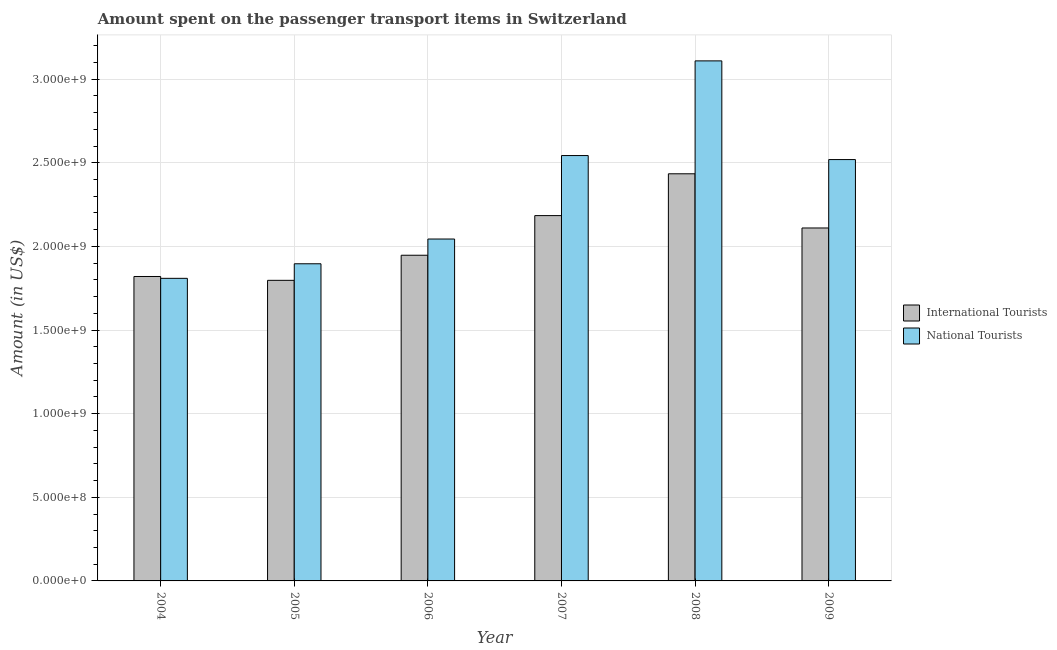How many groups of bars are there?
Your answer should be compact. 6. Are the number of bars per tick equal to the number of legend labels?
Provide a short and direct response. Yes. How many bars are there on the 4th tick from the left?
Make the answer very short. 2. How many bars are there on the 2nd tick from the right?
Offer a terse response. 2. What is the label of the 5th group of bars from the left?
Offer a terse response. 2008. In how many cases, is the number of bars for a given year not equal to the number of legend labels?
Provide a short and direct response. 0. What is the amount spent on transport items of international tourists in 2005?
Your answer should be compact. 1.80e+09. Across all years, what is the maximum amount spent on transport items of international tourists?
Ensure brevity in your answer.  2.43e+09. Across all years, what is the minimum amount spent on transport items of international tourists?
Provide a succinct answer. 1.80e+09. In which year was the amount spent on transport items of national tourists minimum?
Provide a short and direct response. 2004. What is the total amount spent on transport items of national tourists in the graph?
Provide a short and direct response. 1.39e+1. What is the difference between the amount spent on transport items of international tourists in 2008 and that in 2009?
Make the answer very short. 3.24e+08. What is the difference between the amount spent on transport items of national tourists in 2006 and the amount spent on transport items of international tourists in 2007?
Ensure brevity in your answer.  -4.99e+08. What is the average amount spent on transport items of international tourists per year?
Your answer should be compact. 2.05e+09. What is the ratio of the amount spent on transport items of international tourists in 2005 to that in 2009?
Give a very brief answer. 0.85. Is the amount spent on transport items of international tourists in 2007 less than that in 2008?
Ensure brevity in your answer.  Yes. Is the difference between the amount spent on transport items of international tourists in 2008 and 2009 greater than the difference between the amount spent on transport items of national tourists in 2008 and 2009?
Ensure brevity in your answer.  No. What is the difference between the highest and the second highest amount spent on transport items of national tourists?
Your response must be concise. 5.66e+08. What is the difference between the highest and the lowest amount spent on transport items of international tourists?
Ensure brevity in your answer.  6.37e+08. In how many years, is the amount spent on transport items of national tourists greater than the average amount spent on transport items of national tourists taken over all years?
Provide a short and direct response. 3. Is the sum of the amount spent on transport items of national tourists in 2007 and 2009 greater than the maximum amount spent on transport items of international tourists across all years?
Your response must be concise. Yes. What does the 2nd bar from the left in 2005 represents?
Offer a terse response. National Tourists. What does the 1st bar from the right in 2007 represents?
Offer a very short reply. National Tourists. Are the values on the major ticks of Y-axis written in scientific E-notation?
Provide a succinct answer. Yes. Where does the legend appear in the graph?
Your answer should be compact. Center right. What is the title of the graph?
Provide a short and direct response. Amount spent on the passenger transport items in Switzerland. Does "constant 2005 US$" appear as one of the legend labels in the graph?
Offer a very short reply. No. What is the label or title of the X-axis?
Your response must be concise. Year. What is the label or title of the Y-axis?
Provide a succinct answer. Amount (in US$). What is the Amount (in US$) of International Tourists in 2004?
Make the answer very short. 1.82e+09. What is the Amount (in US$) in National Tourists in 2004?
Your answer should be very brief. 1.81e+09. What is the Amount (in US$) of International Tourists in 2005?
Keep it short and to the point. 1.80e+09. What is the Amount (in US$) in National Tourists in 2005?
Offer a terse response. 1.90e+09. What is the Amount (in US$) in International Tourists in 2006?
Your answer should be very brief. 1.95e+09. What is the Amount (in US$) in National Tourists in 2006?
Keep it short and to the point. 2.04e+09. What is the Amount (in US$) in International Tourists in 2007?
Offer a terse response. 2.18e+09. What is the Amount (in US$) in National Tourists in 2007?
Make the answer very short. 2.54e+09. What is the Amount (in US$) in International Tourists in 2008?
Your response must be concise. 2.43e+09. What is the Amount (in US$) of National Tourists in 2008?
Keep it short and to the point. 3.11e+09. What is the Amount (in US$) of International Tourists in 2009?
Your response must be concise. 2.11e+09. What is the Amount (in US$) in National Tourists in 2009?
Provide a short and direct response. 2.52e+09. Across all years, what is the maximum Amount (in US$) in International Tourists?
Your response must be concise. 2.43e+09. Across all years, what is the maximum Amount (in US$) of National Tourists?
Provide a short and direct response. 3.11e+09. Across all years, what is the minimum Amount (in US$) in International Tourists?
Keep it short and to the point. 1.80e+09. Across all years, what is the minimum Amount (in US$) in National Tourists?
Provide a succinct answer. 1.81e+09. What is the total Amount (in US$) in International Tourists in the graph?
Make the answer very short. 1.23e+1. What is the total Amount (in US$) of National Tourists in the graph?
Provide a succinct answer. 1.39e+1. What is the difference between the Amount (in US$) in International Tourists in 2004 and that in 2005?
Keep it short and to the point. 2.30e+07. What is the difference between the Amount (in US$) of National Tourists in 2004 and that in 2005?
Give a very brief answer. -8.70e+07. What is the difference between the Amount (in US$) of International Tourists in 2004 and that in 2006?
Offer a very short reply. -1.27e+08. What is the difference between the Amount (in US$) in National Tourists in 2004 and that in 2006?
Your response must be concise. -2.35e+08. What is the difference between the Amount (in US$) in International Tourists in 2004 and that in 2007?
Offer a terse response. -3.64e+08. What is the difference between the Amount (in US$) of National Tourists in 2004 and that in 2007?
Offer a very short reply. -7.34e+08. What is the difference between the Amount (in US$) of International Tourists in 2004 and that in 2008?
Give a very brief answer. -6.14e+08. What is the difference between the Amount (in US$) in National Tourists in 2004 and that in 2008?
Keep it short and to the point. -1.30e+09. What is the difference between the Amount (in US$) of International Tourists in 2004 and that in 2009?
Offer a very short reply. -2.90e+08. What is the difference between the Amount (in US$) of National Tourists in 2004 and that in 2009?
Your answer should be very brief. -7.10e+08. What is the difference between the Amount (in US$) in International Tourists in 2005 and that in 2006?
Ensure brevity in your answer.  -1.50e+08. What is the difference between the Amount (in US$) of National Tourists in 2005 and that in 2006?
Keep it short and to the point. -1.48e+08. What is the difference between the Amount (in US$) in International Tourists in 2005 and that in 2007?
Your answer should be very brief. -3.87e+08. What is the difference between the Amount (in US$) of National Tourists in 2005 and that in 2007?
Your answer should be compact. -6.47e+08. What is the difference between the Amount (in US$) in International Tourists in 2005 and that in 2008?
Offer a very short reply. -6.37e+08. What is the difference between the Amount (in US$) in National Tourists in 2005 and that in 2008?
Keep it short and to the point. -1.21e+09. What is the difference between the Amount (in US$) of International Tourists in 2005 and that in 2009?
Give a very brief answer. -3.13e+08. What is the difference between the Amount (in US$) of National Tourists in 2005 and that in 2009?
Your answer should be compact. -6.23e+08. What is the difference between the Amount (in US$) of International Tourists in 2006 and that in 2007?
Your answer should be very brief. -2.37e+08. What is the difference between the Amount (in US$) in National Tourists in 2006 and that in 2007?
Offer a terse response. -4.99e+08. What is the difference between the Amount (in US$) of International Tourists in 2006 and that in 2008?
Make the answer very short. -4.87e+08. What is the difference between the Amount (in US$) in National Tourists in 2006 and that in 2008?
Your answer should be compact. -1.06e+09. What is the difference between the Amount (in US$) in International Tourists in 2006 and that in 2009?
Your answer should be compact. -1.63e+08. What is the difference between the Amount (in US$) in National Tourists in 2006 and that in 2009?
Provide a succinct answer. -4.75e+08. What is the difference between the Amount (in US$) in International Tourists in 2007 and that in 2008?
Provide a succinct answer. -2.50e+08. What is the difference between the Amount (in US$) in National Tourists in 2007 and that in 2008?
Give a very brief answer. -5.66e+08. What is the difference between the Amount (in US$) of International Tourists in 2007 and that in 2009?
Keep it short and to the point. 7.40e+07. What is the difference between the Amount (in US$) of National Tourists in 2007 and that in 2009?
Your answer should be very brief. 2.40e+07. What is the difference between the Amount (in US$) of International Tourists in 2008 and that in 2009?
Make the answer very short. 3.24e+08. What is the difference between the Amount (in US$) of National Tourists in 2008 and that in 2009?
Your answer should be compact. 5.90e+08. What is the difference between the Amount (in US$) of International Tourists in 2004 and the Amount (in US$) of National Tourists in 2005?
Offer a terse response. -7.60e+07. What is the difference between the Amount (in US$) in International Tourists in 2004 and the Amount (in US$) in National Tourists in 2006?
Give a very brief answer. -2.24e+08. What is the difference between the Amount (in US$) of International Tourists in 2004 and the Amount (in US$) of National Tourists in 2007?
Ensure brevity in your answer.  -7.23e+08. What is the difference between the Amount (in US$) of International Tourists in 2004 and the Amount (in US$) of National Tourists in 2008?
Provide a short and direct response. -1.29e+09. What is the difference between the Amount (in US$) of International Tourists in 2004 and the Amount (in US$) of National Tourists in 2009?
Your answer should be compact. -6.99e+08. What is the difference between the Amount (in US$) in International Tourists in 2005 and the Amount (in US$) in National Tourists in 2006?
Offer a very short reply. -2.47e+08. What is the difference between the Amount (in US$) in International Tourists in 2005 and the Amount (in US$) in National Tourists in 2007?
Ensure brevity in your answer.  -7.46e+08. What is the difference between the Amount (in US$) in International Tourists in 2005 and the Amount (in US$) in National Tourists in 2008?
Provide a succinct answer. -1.31e+09. What is the difference between the Amount (in US$) of International Tourists in 2005 and the Amount (in US$) of National Tourists in 2009?
Your answer should be compact. -7.22e+08. What is the difference between the Amount (in US$) in International Tourists in 2006 and the Amount (in US$) in National Tourists in 2007?
Ensure brevity in your answer.  -5.96e+08. What is the difference between the Amount (in US$) in International Tourists in 2006 and the Amount (in US$) in National Tourists in 2008?
Offer a terse response. -1.16e+09. What is the difference between the Amount (in US$) of International Tourists in 2006 and the Amount (in US$) of National Tourists in 2009?
Give a very brief answer. -5.72e+08. What is the difference between the Amount (in US$) of International Tourists in 2007 and the Amount (in US$) of National Tourists in 2008?
Your response must be concise. -9.25e+08. What is the difference between the Amount (in US$) of International Tourists in 2007 and the Amount (in US$) of National Tourists in 2009?
Your response must be concise. -3.35e+08. What is the difference between the Amount (in US$) in International Tourists in 2008 and the Amount (in US$) in National Tourists in 2009?
Make the answer very short. -8.50e+07. What is the average Amount (in US$) of International Tourists per year?
Ensure brevity in your answer.  2.05e+09. What is the average Amount (in US$) in National Tourists per year?
Your answer should be compact. 2.32e+09. In the year 2004, what is the difference between the Amount (in US$) in International Tourists and Amount (in US$) in National Tourists?
Give a very brief answer. 1.10e+07. In the year 2005, what is the difference between the Amount (in US$) in International Tourists and Amount (in US$) in National Tourists?
Your answer should be very brief. -9.90e+07. In the year 2006, what is the difference between the Amount (in US$) in International Tourists and Amount (in US$) in National Tourists?
Ensure brevity in your answer.  -9.70e+07. In the year 2007, what is the difference between the Amount (in US$) in International Tourists and Amount (in US$) in National Tourists?
Your response must be concise. -3.59e+08. In the year 2008, what is the difference between the Amount (in US$) of International Tourists and Amount (in US$) of National Tourists?
Your response must be concise. -6.75e+08. In the year 2009, what is the difference between the Amount (in US$) in International Tourists and Amount (in US$) in National Tourists?
Make the answer very short. -4.09e+08. What is the ratio of the Amount (in US$) in International Tourists in 2004 to that in 2005?
Keep it short and to the point. 1.01. What is the ratio of the Amount (in US$) of National Tourists in 2004 to that in 2005?
Give a very brief answer. 0.95. What is the ratio of the Amount (in US$) in International Tourists in 2004 to that in 2006?
Offer a very short reply. 0.93. What is the ratio of the Amount (in US$) of National Tourists in 2004 to that in 2006?
Ensure brevity in your answer.  0.89. What is the ratio of the Amount (in US$) of National Tourists in 2004 to that in 2007?
Your response must be concise. 0.71. What is the ratio of the Amount (in US$) of International Tourists in 2004 to that in 2008?
Make the answer very short. 0.75. What is the ratio of the Amount (in US$) in National Tourists in 2004 to that in 2008?
Give a very brief answer. 0.58. What is the ratio of the Amount (in US$) in International Tourists in 2004 to that in 2009?
Give a very brief answer. 0.86. What is the ratio of the Amount (in US$) in National Tourists in 2004 to that in 2009?
Provide a short and direct response. 0.72. What is the ratio of the Amount (in US$) in International Tourists in 2005 to that in 2006?
Make the answer very short. 0.92. What is the ratio of the Amount (in US$) in National Tourists in 2005 to that in 2006?
Your answer should be compact. 0.93. What is the ratio of the Amount (in US$) of International Tourists in 2005 to that in 2007?
Give a very brief answer. 0.82. What is the ratio of the Amount (in US$) in National Tourists in 2005 to that in 2007?
Provide a succinct answer. 0.75. What is the ratio of the Amount (in US$) of International Tourists in 2005 to that in 2008?
Offer a terse response. 0.74. What is the ratio of the Amount (in US$) in National Tourists in 2005 to that in 2008?
Provide a succinct answer. 0.61. What is the ratio of the Amount (in US$) of International Tourists in 2005 to that in 2009?
Make the answer very short. 0.85. What is the ratio of the Amount (in US$) of National Tourists in 2005 to that in 2009?
Your answer should be compact. 0.75. What is the ratio of the Amount (in US$) in International Tourists in 2006 to that in 2007?
Ensure brevity in your answer.  0.89. What is the ratio of the Amount (in US$) of National Tourists in 2006 to that in 2007?
Your answer should be very brief. 0.8. What is the ratio of the Amount (in US$) in International Tourists in 2006 to that in 2008?
Offer a terse response. 0.8. What is the ratio of the Amount (in US$) of National Tourists in 2006 to that in 2008?
Provide a short and direct response. 0.66. What is the ratio of the Amount (in US$) in International Tourists in 2006 to that in 2009?
Your response must be concise. 0.92. What is the ratio of the Amount (in US$) of National Tourists in 2006 to that in 2009?
Ensure brevity in your answer.  0.81. What is the ratio of the Amount (in US$) in International Tourists in 2007 to that in 2008?
Provide a short and direct response. 0.9. What is the ratio of the Amount (in US$) of National Tourists in 2007 to that in 2008?
Your answer should be compact. 0.82. What is the ratio of the Amount (in US$) of International Tourists in 2007 to that in 2009?
Your answer should be compact. 1.04. What is the ratio of the Amount (in US$) in National Tourists in 2007 to that in 2009?
Offer a terse response. 1.01. What is the ratio of the Amount (in US$) of International Tourists in 2008 to that in 2009?
Provide a succinct answer. 1.15. What is the ratio of the Amount (in US$) in National Tourists in 2008 to that in 2009?
Make the answer very short. 1.23. What is the difference between the highest and the second highest Amount (in US$) in International Tourists?
Make the answer very short. 2.50e+08. What is the difference between the highest and the second highest Amount (in US$) of National Tourists?
Your answer should be very brief. 5.66e+08. What is the difference between the highest and the lowest Amount (in US$) in International Tourists?
Offer a very short reply. 6.37e+08. What is the difference between the highest and the lowest Amount (in US$) of National Tourists?
Keep it short and to the point. 1.30e+09. 